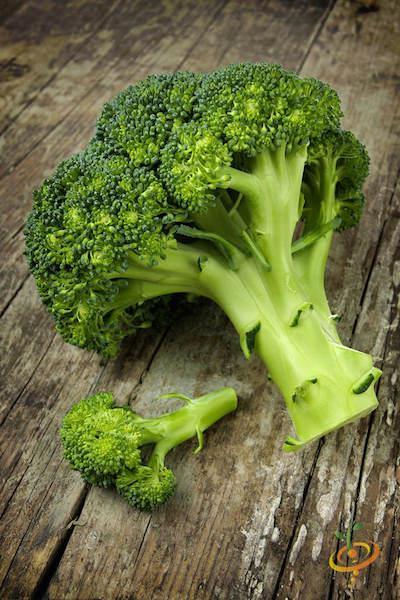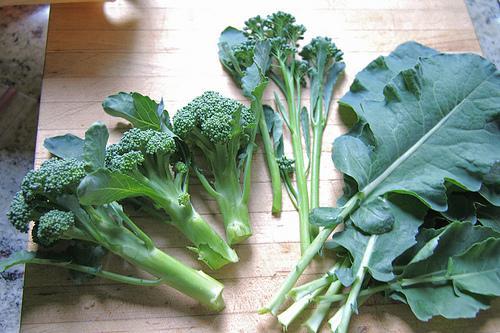The first image is the image on the left, the second image is the image on the right. For the images shown, is this caption "One of the vegetables has purple colored sprouts." true? Answer yes or no. No. The first image is the image on the left, the second image is the image on the right. Evaluate the accuracy of this statement regarding the images: "One photo shows vegetables lying on a rough wooden surface.". Is it true? Answer yes or no. Yes. 